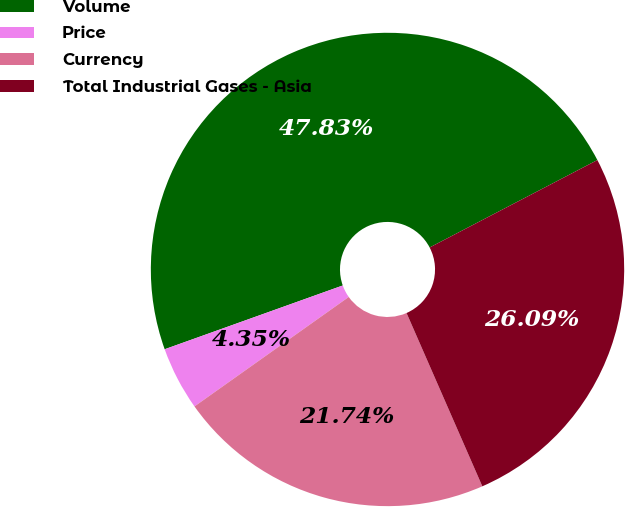Convert chart. <chart><loc_0><loc_0><loc_500><loc_500><pie_chart><fcel>Volume<fcel>Price<fcel>Currency<fcel>Total Industrial Gases - Asia<nl><fcel>47.83%<fcel>4.35%<fcel>21.74%<fcel>26.09%<nl></chart> 